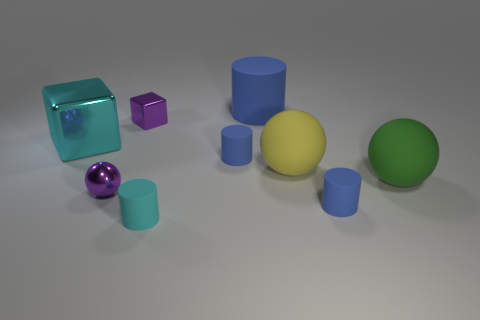Subtract all purple balls. How many blue cylinders are left? 3 Subtract all brown cylinders. Subtract all gray blocks. How many cylinders are left? 4 Add 1 tiny metallic cubes. How many objects exist? 10 Subtract all cubes. How many objects are left? 7 Subtract 0 red cubes. How many objects are left? 9 Subtract all tiny cyan things. Subtract all cylinders. How many objects are left? 4 Add 8 cyan matte cylinders. How many cyan matte cylinders are left? 9 Add 3 tiny gray metallic balls. How many tiny gray metallic balls exist? 3 